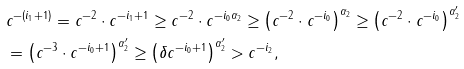Convert formula to latex. <formula><loc_0><loc_0><loc_500><loc_500>& c ^ { - ( i _ { 1 } + 1 ) } = c ^ { - 2 } \cdot c ^ { - i _ { 1 } + 1 } \geq c ^ { - 2 } \cdot c ^ { - i _ { 0 } \alpha _ { 2 } } \geq \left ( c ^ { - 2 } \cdot c ^ { - i _ { 0 } } \right ) ^ { \alpha _ { 2 } } \geq \left ( c ^ { - 2 } \cdot c ^ { - i _ { 0 } } \right ) ^ { \alpha _ { 2 } ^ { \prime } } \\ & = \left ( c ^ { - 3 } \cdot c ^ { - i _ { 0 } + 1 } \right ) ^ { \alpha _ { 2 } ^ { \prime } } \geq \left ( \delta c ^ { - i _ { 0 } + 1 } \right ) ^ { \alpha _ { 2 } ^ { \prime } } > c ^ { - i _ { 2 } } ,</formula> 